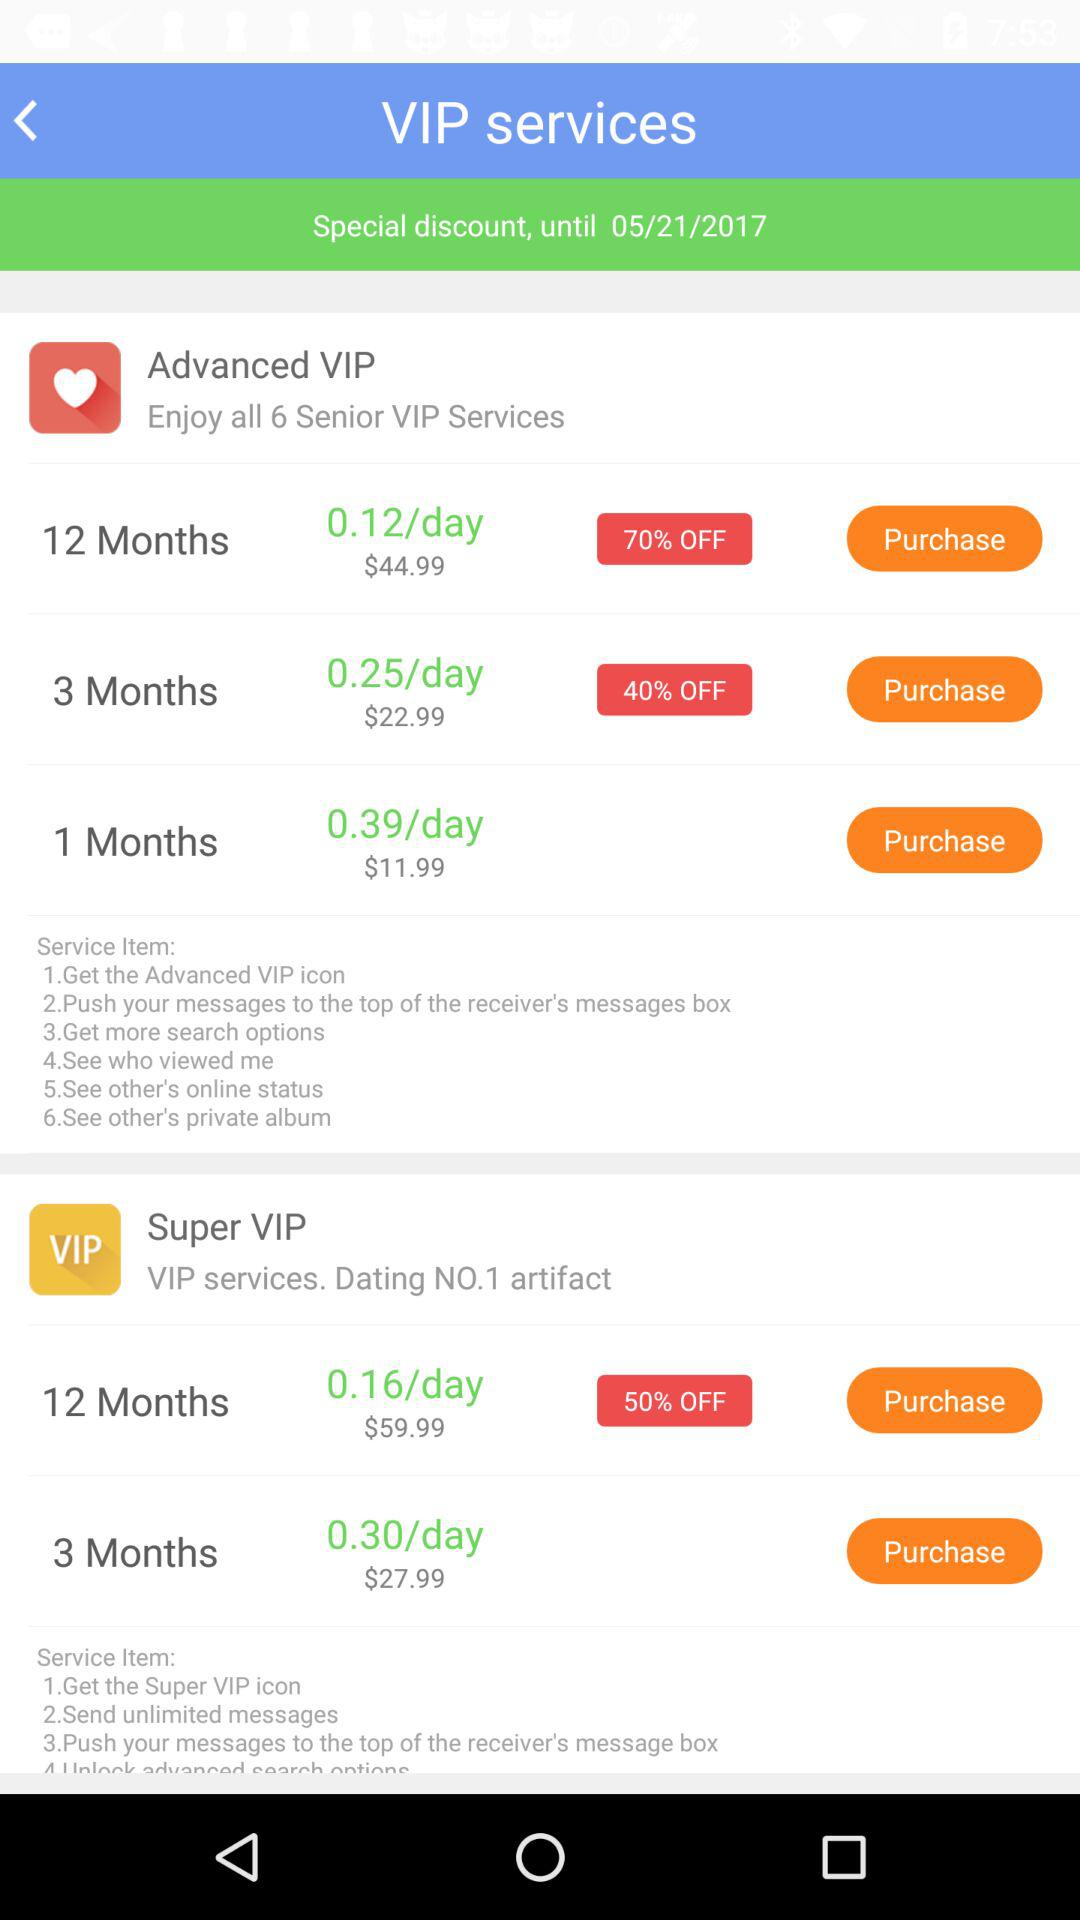Until what date is the special discount applicable? The special discount is applicable until May 21, 2017. 